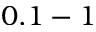Convert formula to latex. <formula><loc_0><loc_0><loc_500><loc_500>0 . 1 - 1</formula> 